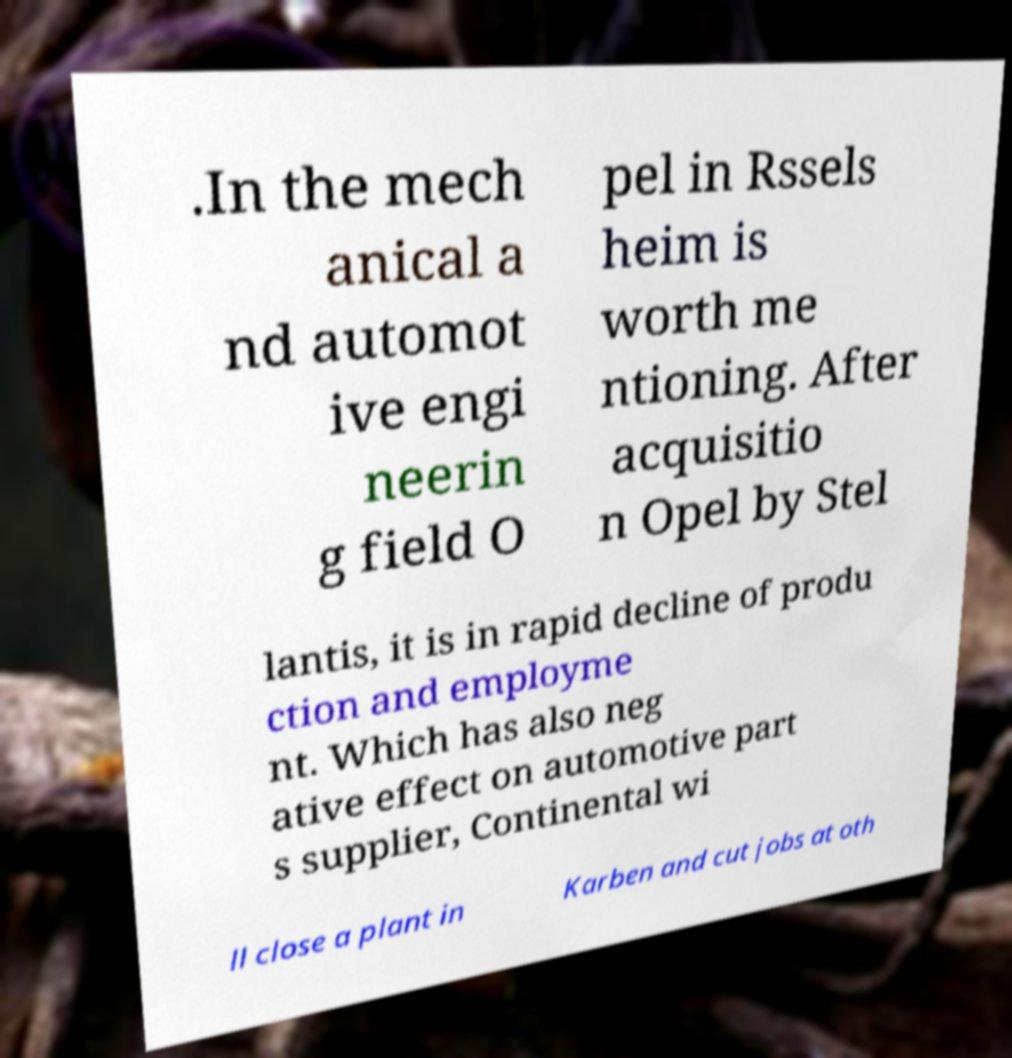Could you extract and type out the text from this image? .In the mech anical a nd automot ive engi neerin g field O pel in Rssels heim is worth me ntioning. After acquisitio n Opel by Stel lantis, it is in rapid decline of produ ction and employme nt. Which has also neg ative effect on automotive part s supplier, Continental wi ll close a plant in Karben and cut jobs at oth 